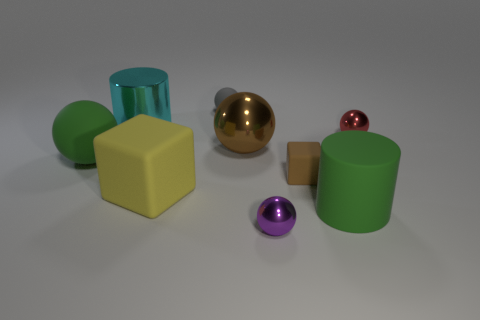Subtract all small balls. How many balls are left? 2 Subtract all cyan cylinders. How many cylinders are left? 1 Subtract 1 cylinders. How many cylinders are left? 1 Add 1 red things. How many objects exist? 10 Subtract all cubes. How many objects are left? 7 Add 7 large yellow shiny cubes. How many large yellow shiny cubes exist? 7 Subtract 0 yellow balls. How many objects are left? 9 Subtract all red cylinders. Subtract all blue blocks. How many cylinders are left? 2 Subtract all shiny things. Subtract all big yellow matte balls. How many objects are left? 5 Add 2 large cyan metallic cylinders. How many large cyan metallic cylinders are left? 3 